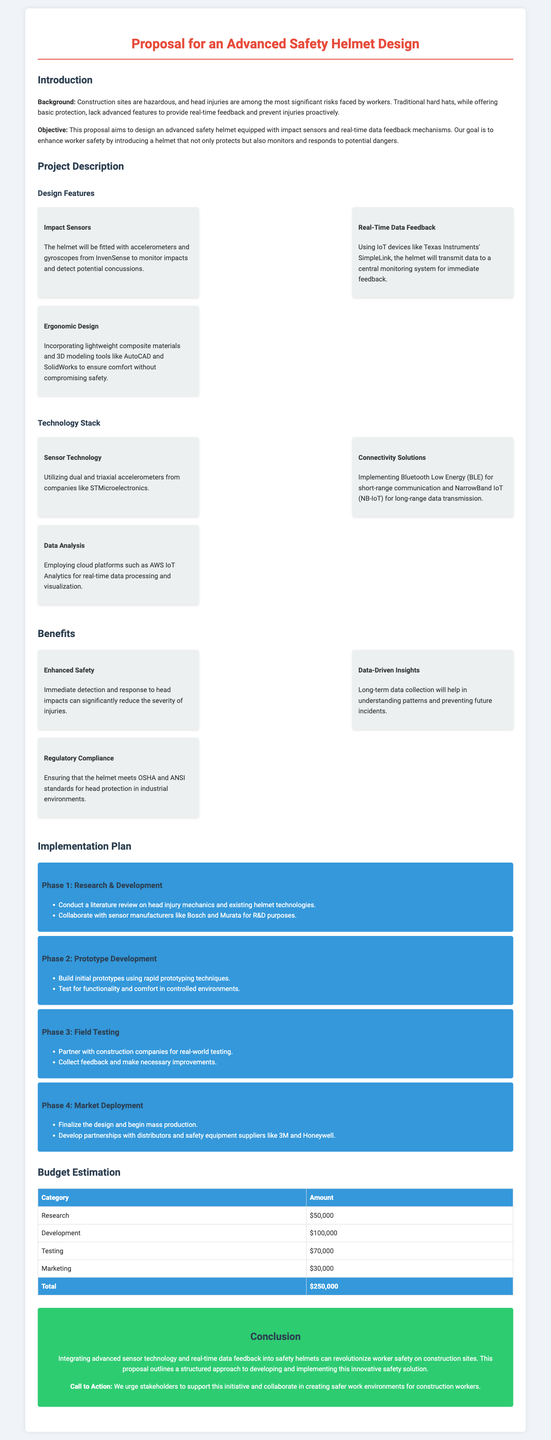What is the objective of the proposal? The objective is to design an advanced safety helmet that enhances worker safety by monitoring and responding to potential dangers.
Answer: Enhance worker safety What technology will be used for real-time data feedback? The helmet will use IoT devices like Texas Instruments' SimpleLink for transmitting data.
Answer: Texas Instruments' SimpleLink How many phases are included in the implementation plan? The implementation plan includes four distinct phases.
Answer: Four What is the budget for development? The development budget is listed as $100,000 in the document.
Answer: $100,000 What type of sensors will be included in the helmet? The helmet will be fitted with accelerometers and gyroscopes to monitor impacts.
Answer: Accelerometers and gyroscopes What is one benefit of data collection mentioned in the proposal? One benefit is understanding patterns and preventing future incidents through long-term data collection.
Answer: Understanding patterns Which company is mentioned for sensor technology? STMicroelectronics is identified as the company providing sensor technology.
Answer: STMicroelectronics What is the total budget estimation according to the proposal? The total budget estimation provided is $250,000.
Answer: $250,000 What is the conclusion's primary message? The conclusion emphasizes the potential of integrating advanced technology into safety helmets to revolutionize worker safety.
Answer: Revolutionize worker safety 